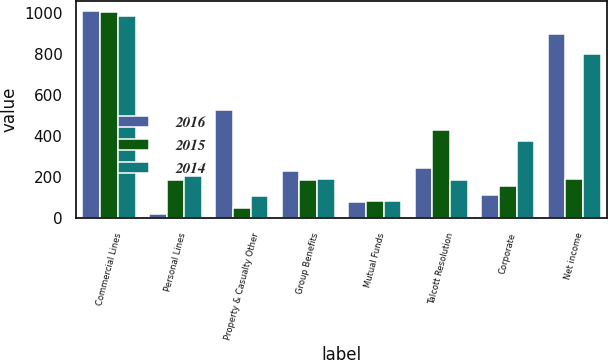Convert chart. <chart><loc_0><loc_0><loc_500><loc_500><stacked_bar_chart><ecel><fcel>Commercial Lines<fcel>Personal Lines<fcel>Property & Casualty Other<fcel>Group Benefits<fcel>Mutual Funds<fcel>Talcott Resolution<fcel>Corporate<fcel>Net income<nl><fcel>2016<fcel>1007<fcel>22<fcel>529<fcel>230<fcel>78<fcel>244<fcel>112<fcel>896<nl><fcel>2015<fcel>1003<fcel>187<fcel>53<fcel>187<fcel>86<fcel>430<fcel>158<fcel>191<nl><fcel>2014<fcel>983<fcel>207<fcel>108<fcel>191<fcel>87<fcel>187<fcel>375<fcel>798<nl></chart> 